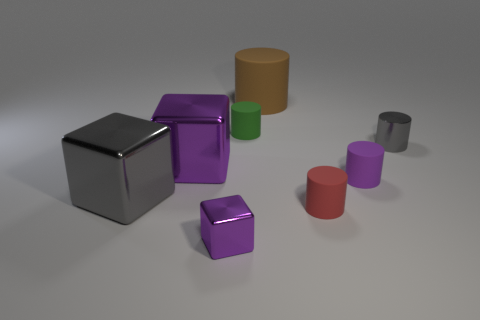How many other objects are there of the same color as the small metal cylinder?
Your response must be concise. 1. The big rubber cylinder has what color?
Your answer should be compact. Brown. There is a purple thing that is both behind the tiny cube and left of the large brown matte thing; what is its size?
Offer a terse response. Large. How many objects are either matte things in front of the brown cylinder or small purple rubber cylinders?
Provide a succinct answer. 3. There is a red object that is the same material as the big cylinder; what is its shape?
Make the answer very short. Cylinder. What is the shape of the brown matte object?
Your answer should be compact. Cylinder. There is a metallic object that is behind the large gray metal thing and on the left side of the gray metallic cylinder; what color is it?
Give a very brief answer. Purple. What shape is the green matte object that is the same size as the purple rubber cylinder?
Keep it short and to the point. Cylinder. Are there any other tiny gray matte objects of the same shape as the tiny gray object?
Provide a short and direct response. No. Are the tiny red object and the gray cylinder to the right of the big brown matte object made of the same material?
Make the answer very short. No. 